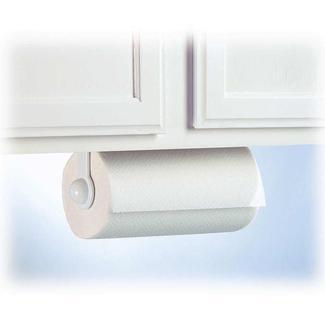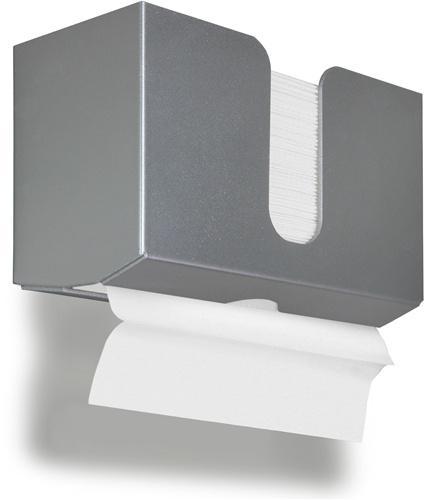The first image is the image on the left, the second image is the image on the right. For the images shown, is this caption "White paper is coming out of a grey dispenser in the image on the right." true? Answer yes or no. Yes. The first image is the image on the left, the second image is the image on the right. Evaluate the accuracy of this statement regarding the images: "The right image shows an opaque gray wall-mount dispenser with a white paper towel hanging below it.". Is it true? Answer yes or no. Yes. 